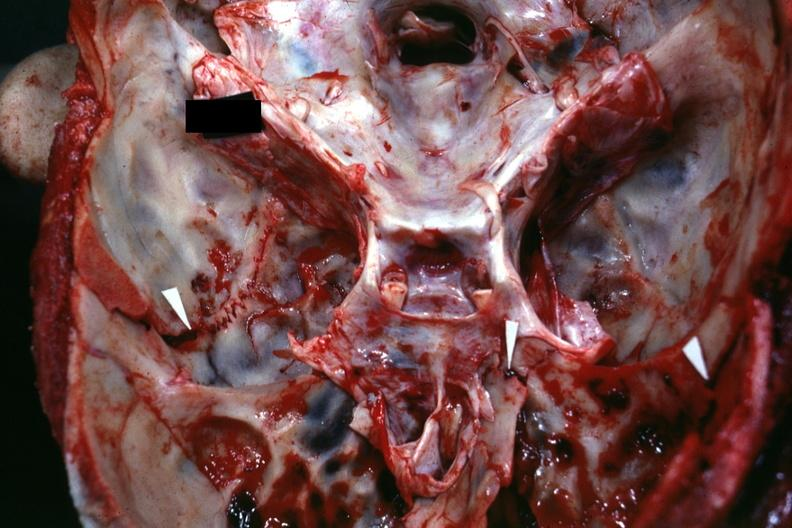s hemorrhagic corpus luteum present?
Answer the question using a single word or phrase. No 